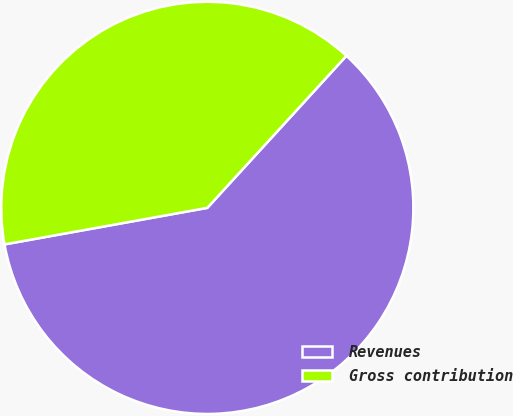Convert chart. <chart><loc_0><loc_0><loc_500><loc_500><pie_chart><fcel>Revenues<fcel>Gross contribution<nl><fcel>60.37%<fcel>39.63%<nl></chart> 